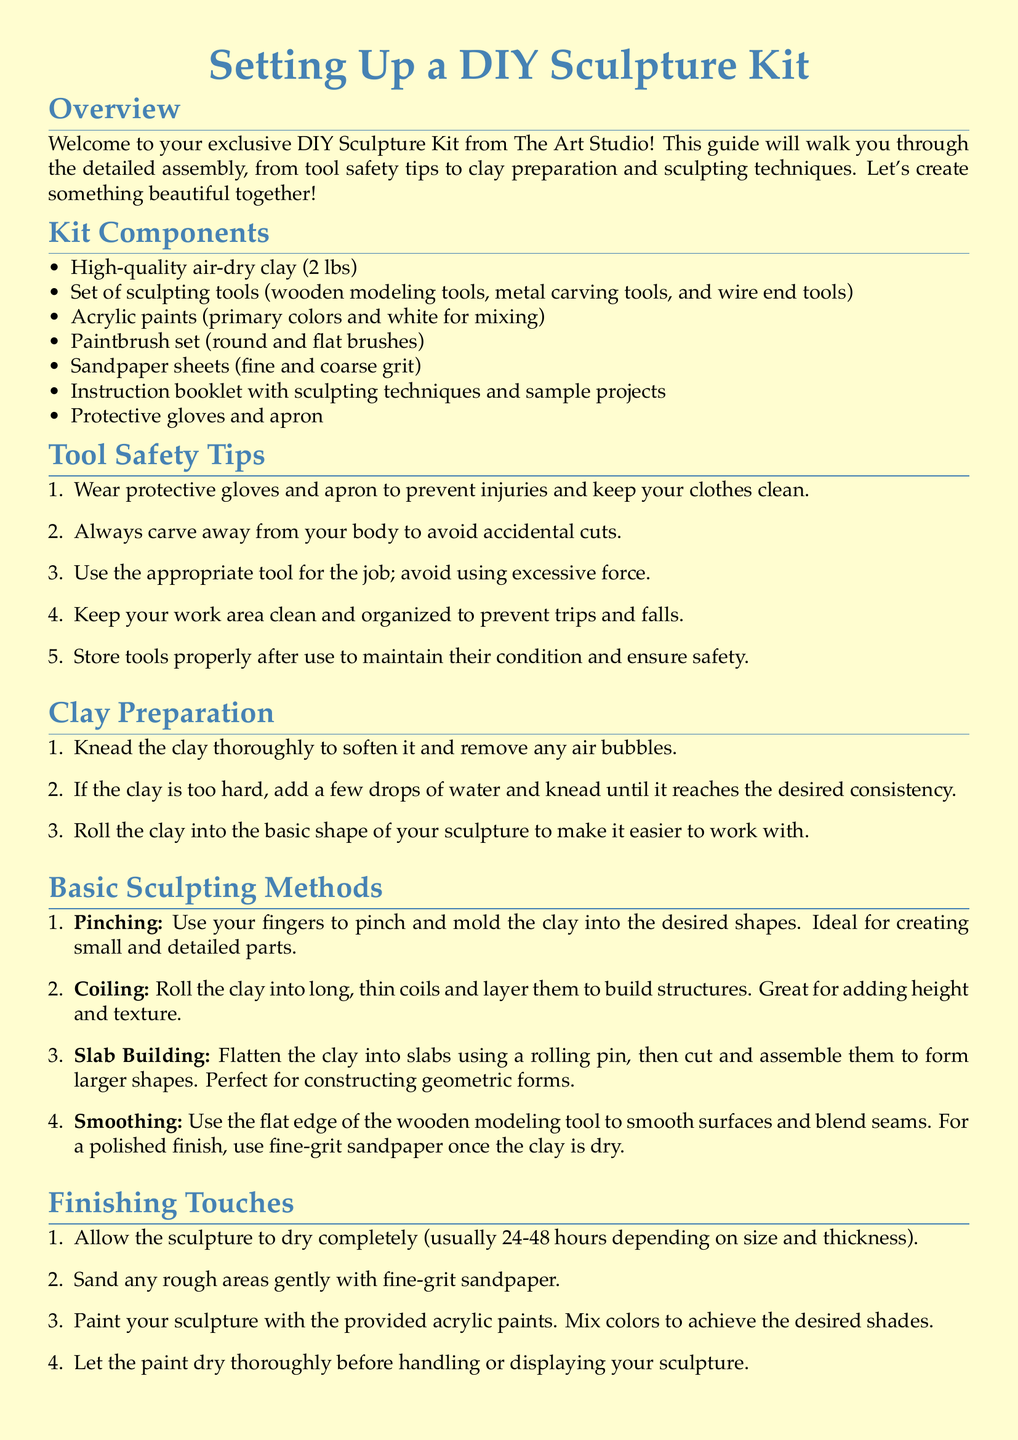What is the weight of the clay included in the kit? The document specifies that the kit contains 2 lbs of clay.
Answer: 2 lbs How many types of brushes are included in the paintbrush set? The document states that the paintbrush set includes round and flat brushes, which implies there are two types.
Answer: 2 types What must you do if the clay is too hard? According to the clay preparation section, you should add a few drops of water and knead it.
Answer: Add water Which sculpting method is ideal for creating small and detailed parts? The document mentions that pinching is the method suited for small and detailed parts.
Answer: Pinching What should you do with your sculpture after painting it? The document advises to let the paint dry thoroughly before handling or displaying the sculpture.
Answer: Let paint dry What is the first step in clay preparation? The first step mentioned for clay preparation is to knead the clay thoroughly.
Answer: Knead clay How long does it usually take for the sculpture to dry completely? The document indicates that drying usually takes 24-48 hours, depending on size and thickness.
Answer: 24-48 hours What safety item should you wear to prevent injuries? The document suggests wearing protective gloves and an apron for safety.
Answer: Gloves and apron 